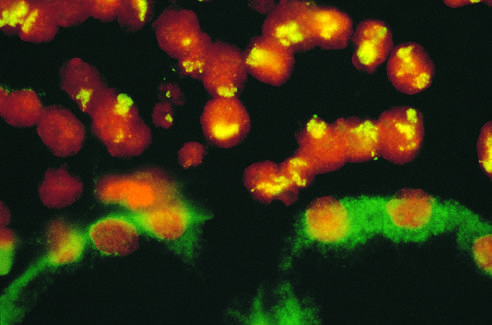what show no nuclear staining and background cytoplasmic staining?
Answer the question using a single word or phrase. Renal tubular epithelial cells 